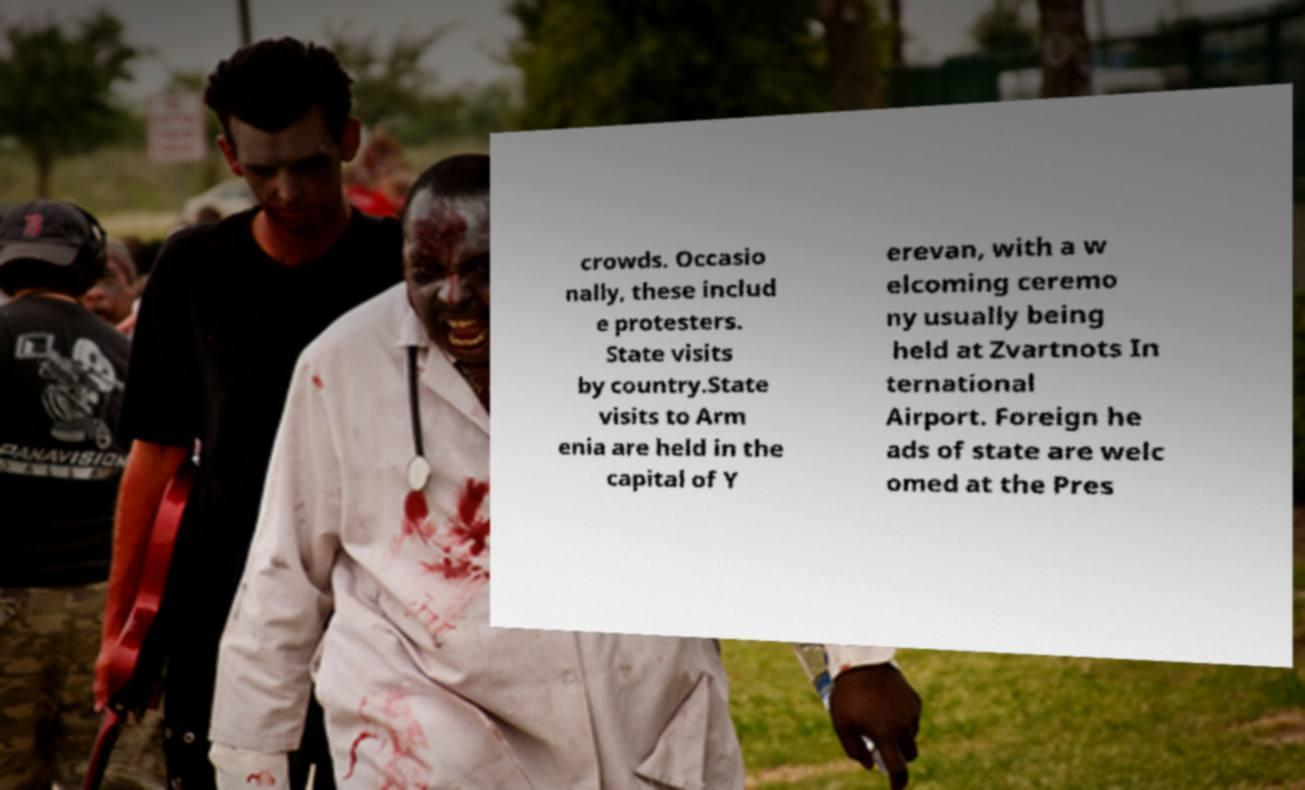Could you extract and type out the text from this image? crowds. Occasio nally, these includ e protesters. State visits by country.State visits to Arm enia are held in the capital of Y erevan, with a w elcoming ceremo ny usually being held at Zvartnots In ternational Airport. Foreign he ads of state are welc omed at the Pres 